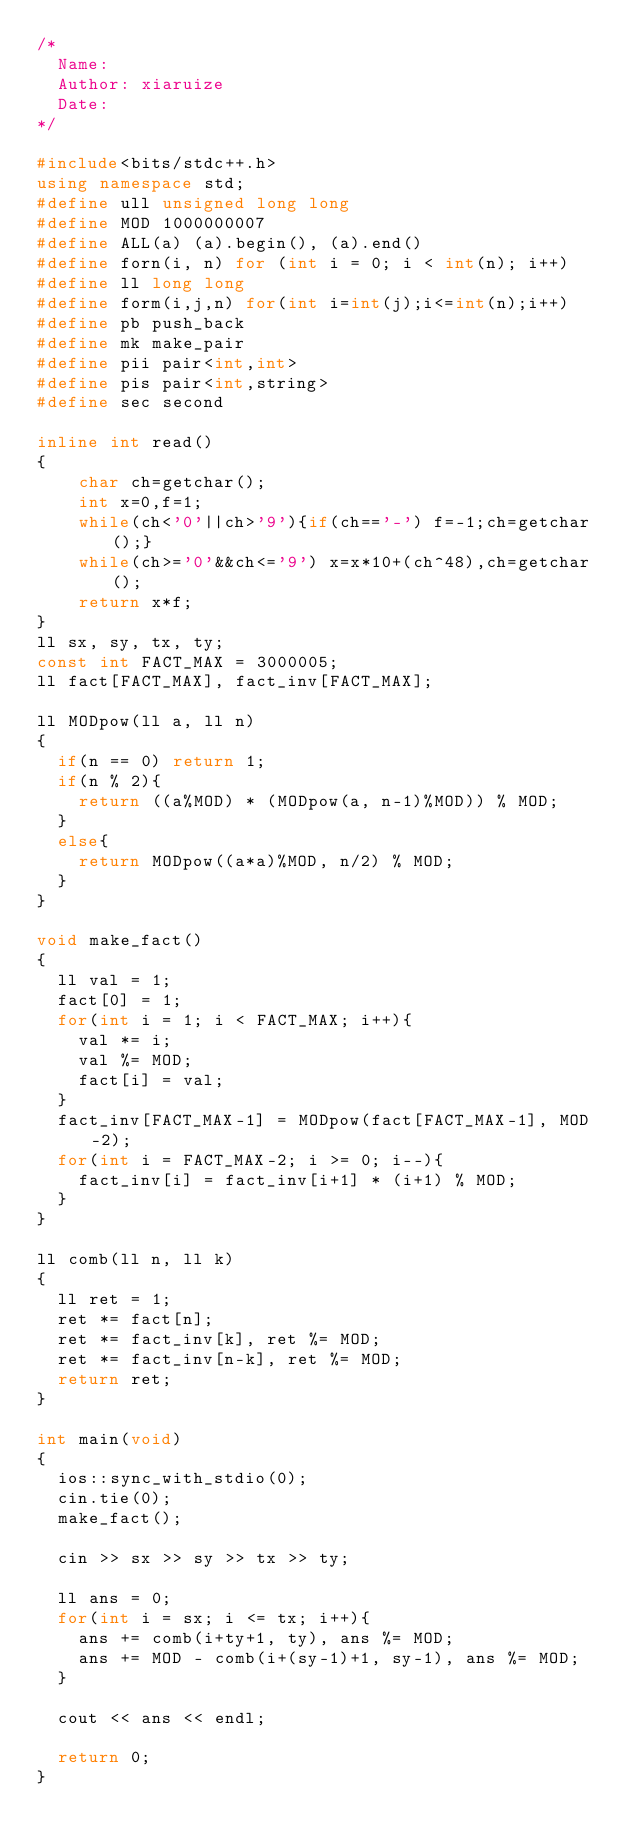Convert code to text. <code><loc_0><loc_0><loc_500><loc_500><_C++_>/*
	Name:
	Author: xiaruize
	Date:
*/

#include<bits/stdc++.h>
using namespace std;
#define ull unsigned long long
#define MOD 1000000007
#define ALL(a) (a).begin(), (a).end()
#define forn(i, n) for (int i = 0; i < int(n); i++)
#define ll long long
#define form(i,j,n) for(int i=int(j);i<=int(n);i++)
#define pb push_back
#define mk make_pair
#define pii pair<int,int>
#define pis pair<int,string>
#define sec second

inline int read()
{
    char ch=getchar();
    int x=0,f=1;
    while(ch<'0'||ch>'9'){if(ch=='-') f=-1;ch=getchar();}
    while(ch>='0'&&ch<='9') x=x*10+(ch^48),ch=getchar();
    return x*f;
}
ll sx, sy, tx, ty;
const int FACT_MAX = 3000005;
ll fact[FACT_MAX], fact_inv[FACT_MAX];

ll MODpow(ll a, ll n)
{
	if(n == 0) return 1;
	if(n % 2){
		return ((a%MOD) * (MODpow(a, n-1)%MOD)) % MOD;
	}
	else{
		return MODpow((a*a)%MOD, n/2) % MOD;
	}
}

void make_fact()
{
	ll val = 1;
	fact[0] = 1;
	for(int i = 1; i < FACT_MAX; i++){
		val *= i;
		val %= MOD;
		fact[i] = val;
	}
	fact_inv[FACT_MAX-1] = MODpow(fact[FACT_MAX-1], MOD-2);
	for(int i = FACT_MAX-2; i >= 0; i--){
		fact_inv[i] = fact_inv[i+1] * (i+1) % MOD;
	}
}

ll comb(ll n, ll k)
{
	ll ret = 1;
	ret *= fact[n];
	ret *= fact_inv[k], ret %= MOD;
	ret *= fact_inv[n-k], ret %= MOD;
	return ret;
}

int main(void)
{
	ios::sync_with_stdio(0);
	cin.tie(0);
	make_fact();
	
	cin >> sx >> sy >> tx >> ty;
	
	ll ans = 0;
	for(int i = sx; i <= tx; i++){
		ans += comb(i+ty+1, ty), ans %= MOD;
		ans += MOD - comb(i+(sy-1)+1, sy-1), ans %= MOD;
	}
	
	cout << ans << endl;
	
	return 0;
}</code> 